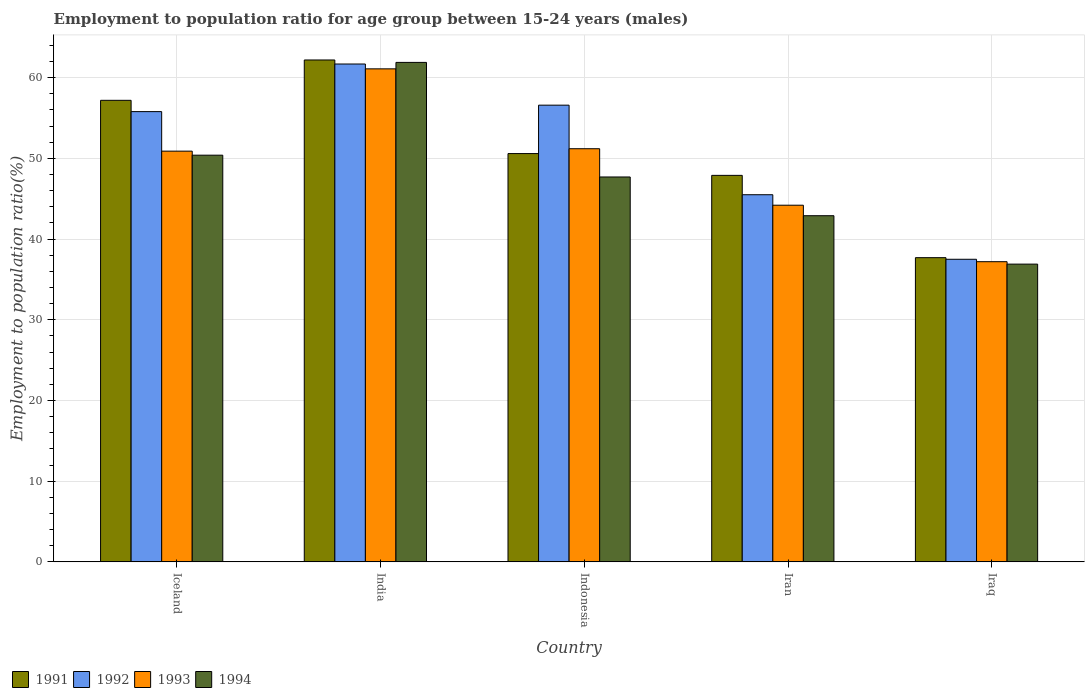How many different coloured bars are there?
Provide a short and direct response. 4. How many groups of bars are there?
Provide a succinct answer. 5. Are the number of bars per tick equal to the number of legend labels?
Make the answer very short. Yes. What is the label of the 5th group of bars from the left?
Ensure brevity in your answer.  Iraq. In how many cases, is the number of bars for a given country not equal to the number of legend labels?
Make the answer very short. 0. What is the employment to population ratio in 1991 in India?
Make the answer very short. 62.2. Across all countries, what is the maximum employment to population ratio in 1994?
Offer a very short reply. 61.9. Across all countries, what is the minimum employment to population ratio in 1993?
Provide a short and direct response. 37.2. In which country was the employment to population ratio in 1993 minimum?
Keep it short and to the point. Iraq. What is the total employment to population ratio in 1993 in the graph?
Offer a terse response. 244.6. What is the difference between the employment to population ratio in 1991 in Iceland and that in Indonesia?
Provide a succinct answer. 6.6. What is the difference between the employment to population ratio in 1994 in Iraq and the employment to population ratio in 1991 in Iceland?
Give a very brief answer. -20.3. What is the average employment to population ratio in 1993 per country?
Ensure brevity in your answer.  48.92. What is the difference between the employment to population ratio of/in 1993 and employment to population ratio of/in 1992 in Iraq?
Provide a short and direct response. -0.3. In how many countries, is the employment to population ratio in 1991 greater than 12 %?
Give a very brief answer. 5. What is the ratio of the employment to population ratio in 1992 in India to that in Iraq?
Ensure brevity in your answer.  1.65. Is the difference between the employment to population ratio in 1993 in India and Iran greater than the difference between the employment to population ratio in 1992 in India and Iran?
Ensure brevity in your answer.  Yes. In how many countries, is the employment to population ratio in 1994 greater than the average employment to population ratio in 1994 taken over all countries?
Your answer should be very brief. 2. What does the 3rd bar from the left in India represents?
Keep it short and to the point. 1993. How many bars are there?
Your answer should be compact. 20. What is the difference between two consecutive major ticks on the Y-axis?
Provide a short and direct response. 10. Are the values on the major ticks of Y-axis written in scientific E-notation?
Provide a succinct answer. No. Does the graph contain any zero values?
Offer a terse response. No. Where does the legend appear in the graph?
Ensure brevity in your answer.  Bottom left. What is the title of the graph?
Ensure brevity in your answer.  Employment to population ratio for age group between 15-24 years (males). Does "1965" appear as one of the legend labels in the graph?
Your answer should be very brief. No. What is the label or title of the X-axis?
Offer a terse response. Country. What is the label or title of the Y-axis?
Keep it short and to the point. Employment to population ratio(%). What is the Employment to population ratio(%) of 1991 in Iceland?
Keep it short and to the point. 57.2. What is the Employment to population ratio(%) in 1992 in Iceland?
Offer a terse response. 55.8. What is the Employment to population ratio(%) of 1993 in Iceland?
Provide a short and direct response. 50.9. What is the Employment to population ratio(%) of 1994 in Iceland?
Your answer should be compact. 50.4. What is the Employment to population ratio(%) in 1991 in India?
Make the answer very short. 62.2. What is the Employment to population ratio(%) of 1992 in India?
Provide a short and direct response. 61.7. What is the Employment to population ratio(%) in 1993 in India?
Your response must be concise. 61.1. What is the Employment to population ratio(%) in 1994 in India?
Ensure brevity in your answer.  61.9. What is the Employment to population ratio(%) of 1991 in Indonesia?
Your response must be concise. 50.6. What is the Employment to population ratio(%) in 1992 in Indonesia?
Make the answer very short. 56.6. What is the Employment to population ratio(%) in 1993 in Indonesia?
Keep it short and to the point. 51.2. What is the Employment to population ratio(%) of 1994 in Indonesia?
Give a very brief answer. 47.7. What is the Employment to population ratio(%) in 1991 in Iran?
Provide a succinct answer. 47.9. What is the Employment to population ratio(%) of 1992 in Iran?
Your answer should be very brief. 45.5. What is the Employment to population ratio(%) of 1993 in Iran?
Make the answer very short. 44.2. What is the Employment to population ratio(%) of 1994 in Iran?
Make the answer very short. 42.9. What is the Employment to population ratio(%) in 1991 in Iraq?
Give a very brief answer. 37.7. What is the Employment to population ratio(%) in 1992 in Iraq?
Ensure brevity in your answer.  37.5. What is the Employment to population ratio(%) of 1993 in Iraq?
Keep it short and to the point. 37.2. What is the Employment to population ratio(%) in 1994 in Iraq?
Your answer should be compact. 36.9. Across all countries, what is the maximum Employment to population ratio(%) in 1991?
Give a very brief answer. 62.2. Across all countries, what is the maximum Employment to population ratio(%) in 1992?
Keep it short and to the point. 61.7. Across all countries, what is the maximum Employment to population ratio(%) of 1993?
Your answer should be very brief. 61.1. Across all countries, what is the maximum Employment to population ratio(%) in 1994?
Keep it short and to the point. 61.9. Across all countries, what is the minimum Employment to population ratio(%) of 1991?
Provide a succinct answer. 37.7. Across all countries, what is the minimum Employment to population ratio(%) of 1992?
Provide a succinct answer. 37.5. Across all countries, what is the minimum Employment to population ratio(%) in 1993?
Provide a short and direct response. 37.2. Across all countries, what is the minimum Employment to population ratio(%) of 1994?
Your answer should be compact. 36.9. What is the total Employment to population ratio(%) of 1991 in the graph?
Offer a terse response. 255.6. What is the total Employment to population ratio(%) of 1992 in the graph?
Give a very brief answer. 257.1. What is the total Employment to population ratio(%) of 1993 in the graph?
Give a very brief answer. 244.6. What is the total Employment to population ratio(%) of 1994 in the graph?
Ensure brevity in your answer.  239.8. What is the difference between the Employment to population ratio(%) of 1991 in Iceland and that in India?
Provide a succinct answer. -5. What is the difference between the Employment to population ratio(%) of 1992 in Iceland and that in India?
Offer a terse response. -5.9. What is the difference between the Employment to population ratio(%) of 1993 in Iceland and that in India?
Make the answer very short. -10.2. What is the difference between the Employment to population ratio(%) in 1994 in Iceland and that in India?
Give a very brief answer. -11.5. What is the difference between the Employment to population ratio(%) in 1992 in Iceland and that in Indonesia?
Your response must be concise. -0.8. What is the difference between the Employment to population ratio(%) of 1993 in Iceland and that in Iran?
Ensure brevity in your answer.  6.7. What is the difference between the Employment to population ratio(%) in 1994 in Iceland and that in Iran?
Provide a succinct answer. 7.5. What is the difference between the Employment to population ratio(%) in 1991 in Iceland and that in Iraq?
Provide a succinct answer. 19.5. What is the difference between the Employment to population ratio(%) of 1992 in Iceland and that in Iraq?
Ensure brevity in your answer.  18.3. What is the difference between the Employment to population ratio(%) in 1993 in Iceland and that in Iraq?
Your response must be concise. 13.7. What is the difference between the Employment to population ratio(%) in 1994 in Iceland and that in Iraq?
Your answer should be very brief. 13.5. What is the difference between the Employment to population ratio(%) of 1993 in India and that in Indonesia?
Your response must be concise. 9.9. What is the difference between the Employment to population ratio(%) of 1992 in India and that in Iran?
Your response must be concise. 16.2. What is the difference between the Employment to population ratio(%) in 1991 in India and that in Iraq?
Make the answer very short. 24.5. What is the difference between the Employment to population ratio(%) of 1992 in India and that in Iraq?
Provide a succinct answer. 24.2. What is the difference between the Employment to population ratio(%) of 1993 in India and that in Iraq?
Offer a terse response. 23.9. What is the difference between the Employment to population ratio(%) of 1992 in Indonesia and that in Iran?
Offer a very short reply. 11.1. What is the difference between the Employment to population ratio(%) of 1993 in Indonesia and that in Iraq?
Keep it short and to the point. 14. What is the difference between the Employment to population ratio(%) of 1994 in Indonesia and that in Iraq?
Provide a succinct answer. 10.8. What is the difference between the Employment to population ratio(%) in 1992 in Iran and that in Iraq?
Provide a short and direct response. 8. What is the difference between the Employment to population ratio(%) in 1992 in Iceland and the Employment to population ratio(%) in 1994 in India?
Ensure brevity in your answer.  -6.1. What is the difference between the Employment to population ratio(%) of 1993 in Iceland and the Employment to population ratio(%) of 1994 in India?
Provide a succinct answer. -11. What is the difference between the Employment to population ratio(%) in 1991 in Iceland and the Employment to population ratio(%) in 1993 in Indonesia?
Offer a terse response. 6. What is the difference between the Employment to population ratio(%) of 1991 in Iceland and the Employment to population ratio(%) of 1994 in Indonesia?
Make the answer very short. 9.5. What is the difference between the Employment to population ratio(%) of 1992 in Iceland and the Employment to population ratio(%) of 1993 in Indonesia?
Provide a succinct answer. 4.6. What is the difference between the Employment to population ratio(%) in 1993 in Iceland and the Employment to population ratio(%) in 1994 in Indonesia?
Keep it short and to the point. 3.2. What is the difference between the Employment to population ratio(%) of 1991 in Iceland and the Employment to population ratio(%) of 1993 in Iran?
Offer a terse response. 13. What is the difference between the Employment to population ratio(%) in 1991 in Iceland and the Employment to population ratio(%) in 1994 in Iran?
Keep it short and to the point. 14.3. What is the difference between the Employment to population ratio(%) of 1992 in Iceland and the Employment to population ratio(%) of 1993 in Iran?
Your answer should be compact. 11.6. What is the difference between the Employment to population ratio(%) of 1993 in Iceland and the Employment to population ratio(%) of 1994 in Iran?
Your response must be concise. 8. What is the difference between the Employment to population ratio(%) in 1991 in Iceland and the Employment to population ratio(%) in 1992 in Iraq?
Your answer should be compact. 19.7. What is the difference between the Employment to population ratio(%) of 1991 in Iceland and the Employment to population ratio(%) of 1994 in Iraq?
Your answer should be compact. 20.3. What is the difference between the Employment to population ratio(%) in 1992 in Iceland and the Employment to population ratio(%) in 1994 in Iraq?
Ensure brevity in your answer.  18.9. What is the difference between the Employment to population ratio(%) in 1993 in Iceland and the Employment to population ratio(%) in 1994 in Iraq?
Your answer should be compact. 14. What is the difference between the Employment to population ratio(%) of 1991 in India and the Employment to population ratio(%) of 1992 in Indonesia?
Offer a very short reply. 5.6. What is the difference between the Employment to population ratio(%) in 1991 in India and the Employment to population ratio(%) in 1993 in Indonesia?
Provide a short and direct response. 11. What is the difference between the Employment to population ratio(%) in 1991 in India and the Employment to population ratio(%) in 1994 in Indonesia?
Your answer should be compact. 14.5. What is the difference between the Employment to population ratio(%) in 1992 in India and the Employment to population ratio(%) in 1993 in Indonesia?
Keep it short and to the point. 10.5. What is the difference between the Employment to population ratio(%) in 1993 in India and the Employment to population ratio(%) in 1994 in Indonesia?
Offer a very short reply. 13.4. What is the difference between the Employment to population ratio(%) in 1991 in India and the Employment to population ratio(%) in 1993 in Iran?
Your answer should be compact. 18. What is the difference between the Employment to population ratio(%) in 1991 in India and the Employment to population ratio(%) in 1994 in Iran?
Make the answer very short. 19.3. What is the difference between the Employment to population ratio(%) of 1992 in India and the Employment to population ratio(%) of 1994 in Iran?
Make the answer very short. 18.8. What is the difference between the Employment to population ratio(%) in 1991 in India and the Employment to population ratio(%) in 1992 in Iraq?
Give a very brief answer. 24.7. What is the difference between the Employment to population ratio(%) of 1991 in India and the Employment to population ratio(%) of 1994 in Iraq?
Give a very brief answer. 25.3. What is the difference between the Employment to population ratio(%) in 1992 in India and the Employment to population ratio(%) in 1993 in Iraq?
Your answer should be compact. 24.5. What is the difference between the Employment to population ratio(%) in 1992 in India and the Employment to population ratio(%) in 1994 in Iraq?
Provide a succinct answer. 24.8. What is the difference between the Employment to population ratio(%) of 1993 in India and the Employment to population ratio(%) of 1994 in Iraq?
Offer a terse response. 24.2. What is the difference between the Employment to population ratio(%) in 1991 in Indonesia and the Employment to population ratio(%) in 1993 in Iran?
Provide a short and direct response. 6.4. What is the difference between the Employment to population ratio(%) of 1991 in Indonesia and the Employment to population ratio(%) of 1994 in Iran?
Ensure brevity in your answer.  7.7. What is the difference between the Employment to population ratio(%) of 1992 in Indonesia and the Employment to population ratio(%) of 1993 in Iran?
Keep it short and to the point. 12.4. What is the difference between the Employment to population ratio(%) in 1992 in Indonesia and the Employment to population ratio(%) in 1994 in Iran?
Make the answer very short. 13.7. What is the difference between the Employment to population ratio(%) of 1993 in Indonesia and the Employment to population ratio(%) of 1994 in Iran?
Ensure brevity in your answer.  8.3. What is the difference between the Employment to population ratio(%) of 1992 in Indonesia and the Employment to population ratio(%) of 1993 in Iraq?
Your answer should be very brief. 19.4. What is the difference between the Employment to population ratio(%) of 1993 in Indonesia and the Employment to population ratio(%) of 1994 in Iraq?
Offer a very short reply. 14.3. What is the difference between the Employment to population ratio(%) in 1992 in Iran and the Employment to population ratio(%) in 1993 in Iraq?
Ensure brevity in your answer.  8.3. What is the difference between the Employment to population ratio(%) in 1993 in Iran and the Employment to population ratio(%) in 1994 in Iraq?
Give a very brief answer. 7.3. What is the average Employment to population ratio(%) in 1991 per country?
Give a very brief answer. 51.12. What is the average Employment to population ratio(%) in 1992 per country?
Offer a very short reply. 51.42. What is the average Employment to population ratio(%) in 1993 per country?
Offer a terse response. 48.92. What is the average Employment to population ratio(%) in 1994 per country?
Your answer should be compact. 47.96. What is the difference between the Employment to population ratio(%) in 1991 and Employment to population ratio(%) in 1992 in Iceland?
Make the answer very short. 1.4. What is the difference between the Employment to population ratio(%) in 1992 and Employment to population ratio(%) in 1994 in Iceland?
Offer a very short reply. 5.4. What is the difference between the Employment to population ratio(%) in 1991 and Employment to population ratio(%) in 1994 in India?
Give a very brief answer. 0.3. What is the difference between the Employment to population ratio(%) of 1992 and Employment to population ratio(%) of 1993 in India?
Keep it short and to the point. 0.6. What is the difference between the Employment to population ratio(%) of 1992 and Employment to population ratio(%) of 1994 in India?
Your response must be concise. -0.2. What is the difference between the Employment to population ratio(%) of 1993 and Employment to population ratio(%) of 1994 in India?
Ensure brevity in your answer.  -0.8. What is the difference between the Employment to population ratio(%) in 1991 and Employment to population ratio(%) in 1992 in Indonesia?
Your answer should be very brief. -6. What is the difference between the Employment to population ratio(%) in 1991 and Employment to population ratio(%) in 1993 in Indonesia?
Offer a very short reply. -0.6. What is the difference between the Employment to population ratio(%) of 1991 and Employment to population ratio(%) of 1994 in Indonesia?
Keep it short and to the point. 2.9. What is the difference between the Employment to population ratio(%) of 1993 and Employment to population ratio(%) of 1994 in Indonesia?
Your answer should be compact. 3.5. What is the difference between the Employment to population ratio(%) of 1991 and Employment to population ratio(%) of 1992 in Iran?
Offer a terse response. 2.4. What is the difference between the Employment to population ratio(%) of 1992 and Employment to population ratio(%) of 1994 in Iran?
Make the answer very short. 2.6. What is the difference between the Employment to population ratio(%) in 1993 and Employment to population ratio(%) in 1994 in Iran?
Your answer should be very brief. 1.3. What is the difference between the Employment to population ratio(%) of 1991 and Employment to population ratio(%) of 1992 in Iraq?
Make the answer very short. 0.2. What is the difference between the Employment to population ratio(%) in 1991 and Employment to population ratio(%) in 1993 in Iraq?
Give a very brief answer. 0.5. What is the ratio of the Employment to population ratio(%) in 1991 in Iceland to that in India?
Ensure brevity in your answer.  0.92. What is the ratio of the Employment to population ratio(%) in 1992 in Iceland to that in India?
Your answer should be very brief. 0.9. What is the ratio of the Employment to population ratio(%) of 1993 in Iceland to that in India?
Your response must be concise. 0.83. What is the ratio of the Employment to population ratio(%) in 1994 in Iceland to that in India?
Provide a short and direct response. 0.81. What is the ratio of the Employment to population ratio(%) of 1991 in Iceland to that in Indonesia?
Your response must be concise. 1.13. What is the ratio of the Employment to population ratio(%) of 1992 in Iceland to that in Indonesia?
Your answer should be compact. 0.99. What is the ratio of the Employment to population ratio(%) of 1993 in Iceland to that in Indonesia?
Your response must be concise. 0.99. What is the ratio of the Employment to population ratio(%) of 1994 in Iceland to that in Indonesia?
Make the answer very short. 1.06. What is the ratio of the Employment to population ratio(%) in 1991 in Iceland to that in Iran?
Ensure brevity in your answer.  1.19. What is the ratio of the Employment to population ratio(%) of 1992 in Iceland to that in Iran?
Your answer should be compact. 1.23. What is the ratio of the Employment to population ratio(%) of 1993 in Iceland to that in Iran?
Your answer should be compact. 1.15. What is the ratio of the Employment to population ratio(%) of 1994 in Iceland to that in Iran?
Your answer should be compact. 1.17. What is the ratio of the Employment to population ratio(%) in 1991 in Iceland to that in Iraq?
Your answer should be very brief. 1.52. What is the ratio of the Employment to population ratio(%) of 1992 in Iceland to that in Iraq?
Make the answer very short. 1.49. What is the ratio of the Employment to population ratio(%) of 1993 in Iceland to that in Iraq?
Ensure brevity in your answer.  1.37. What is the ratio of the Employment to population ratio(%) in 1994 in Iceland to that in Iraq?
Provide a succinct answer. 1.37. What is the ratio of the Employment to population ratio(%) of 1991 in India to that in Indonesia?
Make the answer very short. 1.23. What is the ratio of the Employment to population ratio(%) in 1992 in India to that in Indonesia?
Provide a succinct answer. 1.09. What is the ratio of the Employment to population ratio(%) in 1993 in India to that in Indonesia?
Your answer should be compact. 1.19. What is the ratio of the Employment to population ratio(%) in 1994 in India to that in Indonesia?
Provide a succinct answer. 1.3. What is the ratio of the Employment to population ratio(%) of 1991 in India to that in Iran?
Make the answer very short. 1.3. What is the ratio of the Employment to population ratio(%) of 1992 in India to that in Iran?
Provide a short and direct response. 1.36. What is the ratio of the Employment to population ratio(%) of 1993 in India to that in Iran?
Offer a terse response. 1.38. What is the ratio of the Employment to population ratio(%) of 1994 in India to that in Iran?
Your answer should be compact. 1.44. What is the ratio of the Employment to population ratio(%) of 1991 in India to that in Iraq?
Provide a succinct answer. 1.65. What is the ratio of the Employment to population ratio(%) in 1992 in India to that in Iraq?
Provide a short and direct response. 1.65. What is the ratio of the Employment to population ratio(%) of 1993 in India to that in Iraq?
Offer a terse response. 1.64. What is the ratio of the Employment to population ratio(%) of 1994 in India to that in Iraq?
Your response must be concise. 1.68. What is the ratio of the Employment to population ratio(%) in 1991 in Indonesia to that in Iran?
Keep it short and to the point. 1.06. What is the ratio of the Employment to population ratio(%) of 1992 in Indonesia to that in Iran?
Ensure brevity in your answer.  1.24. What is the ratio of the Employment to population ratio(%) in 1993 in Indonesia to that in Iran?
Ensure brevity in your answer.  1.16. What is the ratio of the Employment to population ratio(%) in 1994 in Indonesia to that in Iran?
Make the answer very short. 1.11. What is the ratio of the Employment to population ratio(%) of 1991 in Indonesia to that in Iraq?
Offer a terse response. 1.34. What is the ratio of the Employment to population ratio(%) of 1992 in Indonesia to that in Iraq?
Your answer should be compact. 1.51. What is the ratio of the Employment to population ratio(%) of 1993 in Indonesia to that in Iraq?
Provide a short and direct response. 1.38. What is the ratio of the Employment to population ratio(%) of 1994 in Indonesia to that in Iraq?
Provide a succinct answer. 1.29. What is the ratio of the Employment to population ratio(%) of 1991 in Iran to that in Iraq?
Your answer should be very brief. 1.27. What is the ratio of the Employment to population ratio(%) of 1992 in Iran to that in Iraq?
Your answer should be very brief. 1.21. What is the ratio of the Employment to population ratio(%) of 1993 in Iran to that in Iraq?
Give a very brief answer. 1.19. What is the ratio of the Employment to population ratio(%) in 1994 in Iran to that in Iraq?
Keep it short and to the point. 1.16. What is the difference between the highest and the second highest Employment to population ratio(%) in 1992?
Ensure brevity in your answer.  5.1. What is the difference between the highest and the lowest Employment to population ratio(%) of 1992?
Your answer should be very brief. 24.2. What is the difference between the highest and the lowest Employment to population ratio(%) in 1993?
Ensure brevity in your answer.  23.9. What is the difference between the highest and the lowest Employment to population ratio(%) of 1994?
Give a very brief answer. 25. 